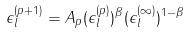<formula> <loc_0><loc_0><loc_500><loc_500>\epsilon _ { l } ^ { ( p + 1 ) } = A _ { p } ( \epsilon _ { l } ^ { ( p ) } ) ^ { \beta } ( \epsilon _ { l } ^ { ( \infty ) } ) ^ { 1 - \beta }</formula> 